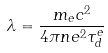<formula> <loc_0><loc_0><loc_500><loc_500>\lambda = \frac { m _ { e } c ^ { 2 } } { 4 \pi n e ^ { 2 } \tau _ { d } ^ { e } }</formula> 